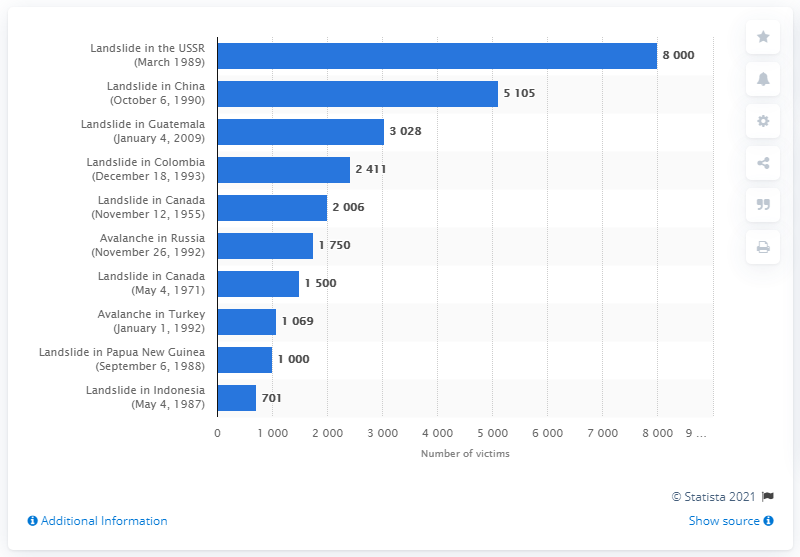Specify some key components in this picture. A landslide in China impacted 5,105 individuals. In the landslide that occurred between 1989 and 1990, a total of 13,105 people were affected. 